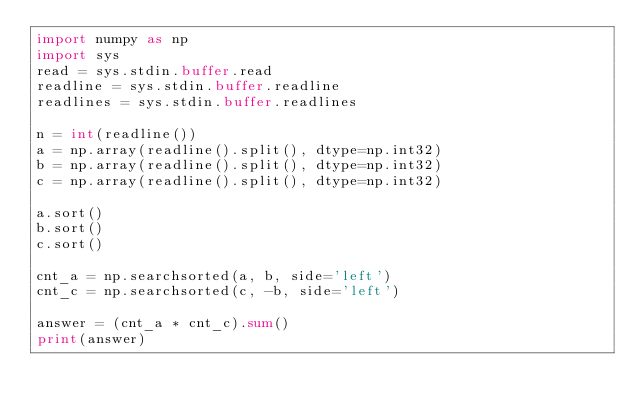Convert code to text. <code><loc_0><loc_0><loc_500><loc_500><_Python_>import numpy as np
import sys
read = sys.stdin.buffer.read
readline = sys.stdin.buffer.readline
readlines = sys.stdin.buffer.readlines

n = int(readline())
a = np.array(readline().split(), dtype=np.int32)
b = np.array(readline().split(), dtype=np.int32)
c = np.array(readline().split(), dtype=np.int32)

a.sort()
b.sort()
c.sort()

cnt_a = np.searchsorted(a, b, side='left')
cnt_c = np.searchsorted(c, -b, side='left')
 
answer = (cnt_a * cnt_c).sum()
print(answer)
</code> 